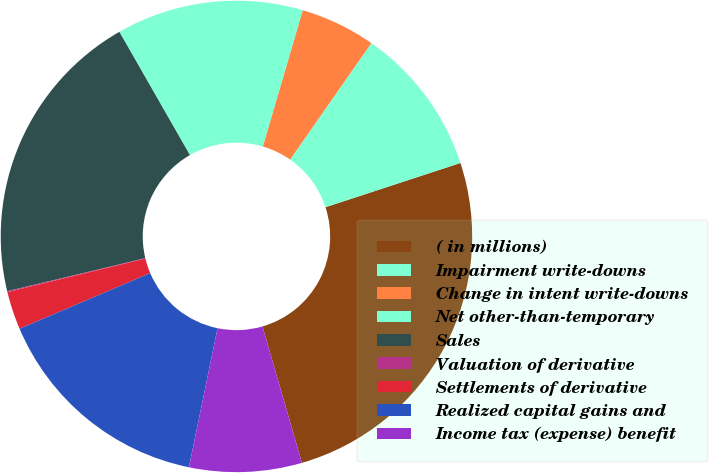Convert chart. <chart><loc_0><loc_0><loc_500><loc_500><pie_chart><fcel>( in millions)<fcel>Impairment write-downs<fcel>Change in intent write-downs<fcel>Net other-than-temporary<fcel>Sales<fcel>Valuation of derivative<fcel>Settlements of derivative<fcel>Realized capital gains and<fcel>Income tax (expense) benefit<nl><fcel>25.56%<fcel>10.26%<fcel>5.16%<fcel>12.81%<fcel>20.46%<fcel>0.06%<fcel>2.61%<fcel>15.36%<fcel>7.71%<nl></chart> 